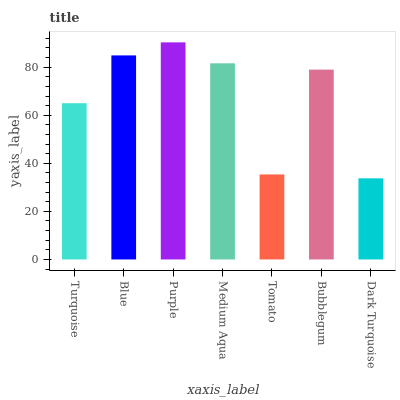Is Dark Turquoise the minimum?
Answer yes or no. Yes. Is Purple the maximum?
Answer yes or no. Yes. Is Blue the minimum?
Answer yes or no. No. Is Blue the maximum?
Answer yes or no. No. Is Blue greater than Turquoise?
Answer yes or no. Yes. Is Turquoise less than Blue?
Answer yes or no. Yes. Is Turquoise greater than Blue?
Answer yes or no. No. Is Blue less than Turquoise?
Answer yes or no. No. Is Bubblegum the high median?
Answer yes or no. Yes. Is Bubblegum the low median?
Answer yes or no. Yes. Is Tomato the high median?
Answer yes or no. No. Is Tomato the low median?
Answer yes or no. No. 